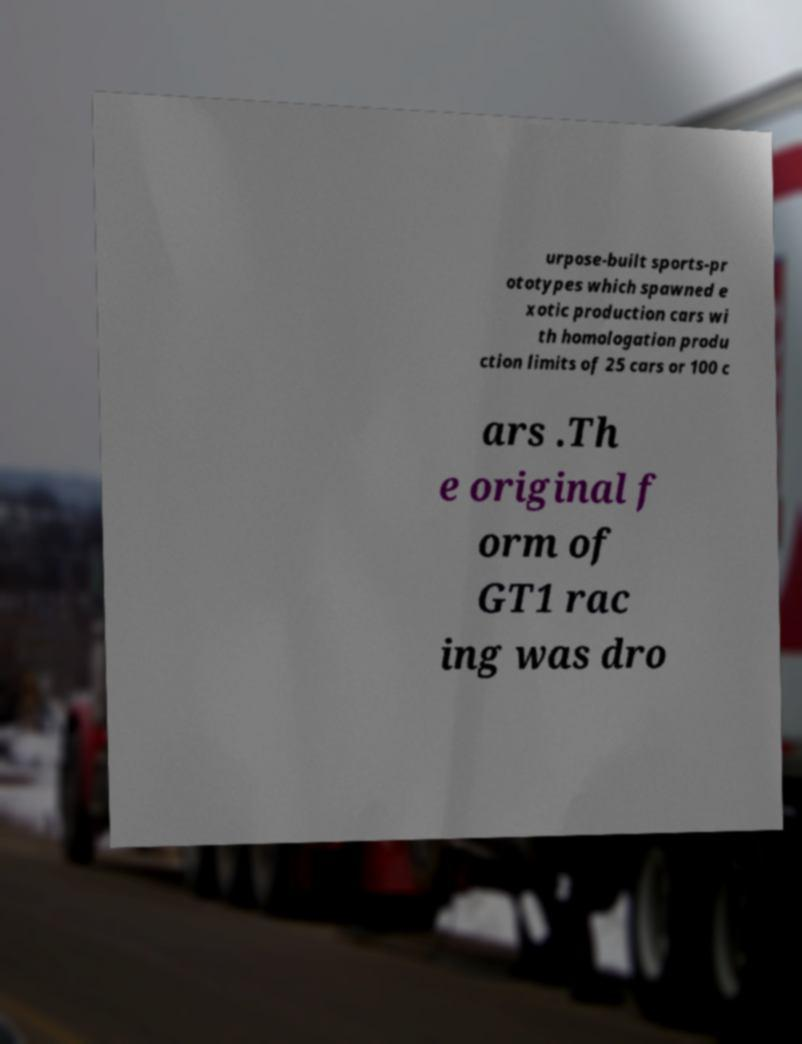What messages or text are displayed in this image? I need them in a readable, typed format. urpose-built sports-pr ototypes which spawned e xotic production cars wi th homologation produ ction limits of 25 cars or 100 c ars .Th e original f orm of GT1 rac ing was dro 